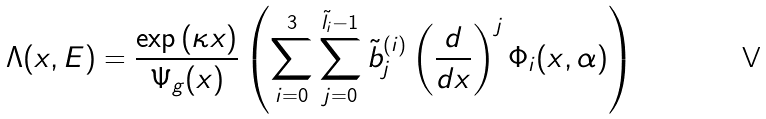Convert formula to latex. <formula><loc_0><loc_0><loc_500><loc_500>& \Lambda ( x , E ) = \frac { \exp \left ( \kappa x \right ) } { \Psi _ { g } ( x ) } \left ( \sum _ { i = 0 } ^ { 3 } \sum _ { j = 0 } ^ { \tilde { l } _ { i } - 1 } \tilde { b } ^ { ( i ) } _ { j } \left ( \frac { d } { d x } \right ) ^ { j } \Phi _ { i } ( x , \alpha ) \right )</formula> 